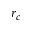Convert formula to latex. <formula><loc_0><loc_0><loc_500><loc_500>r _ { c }</formula> 